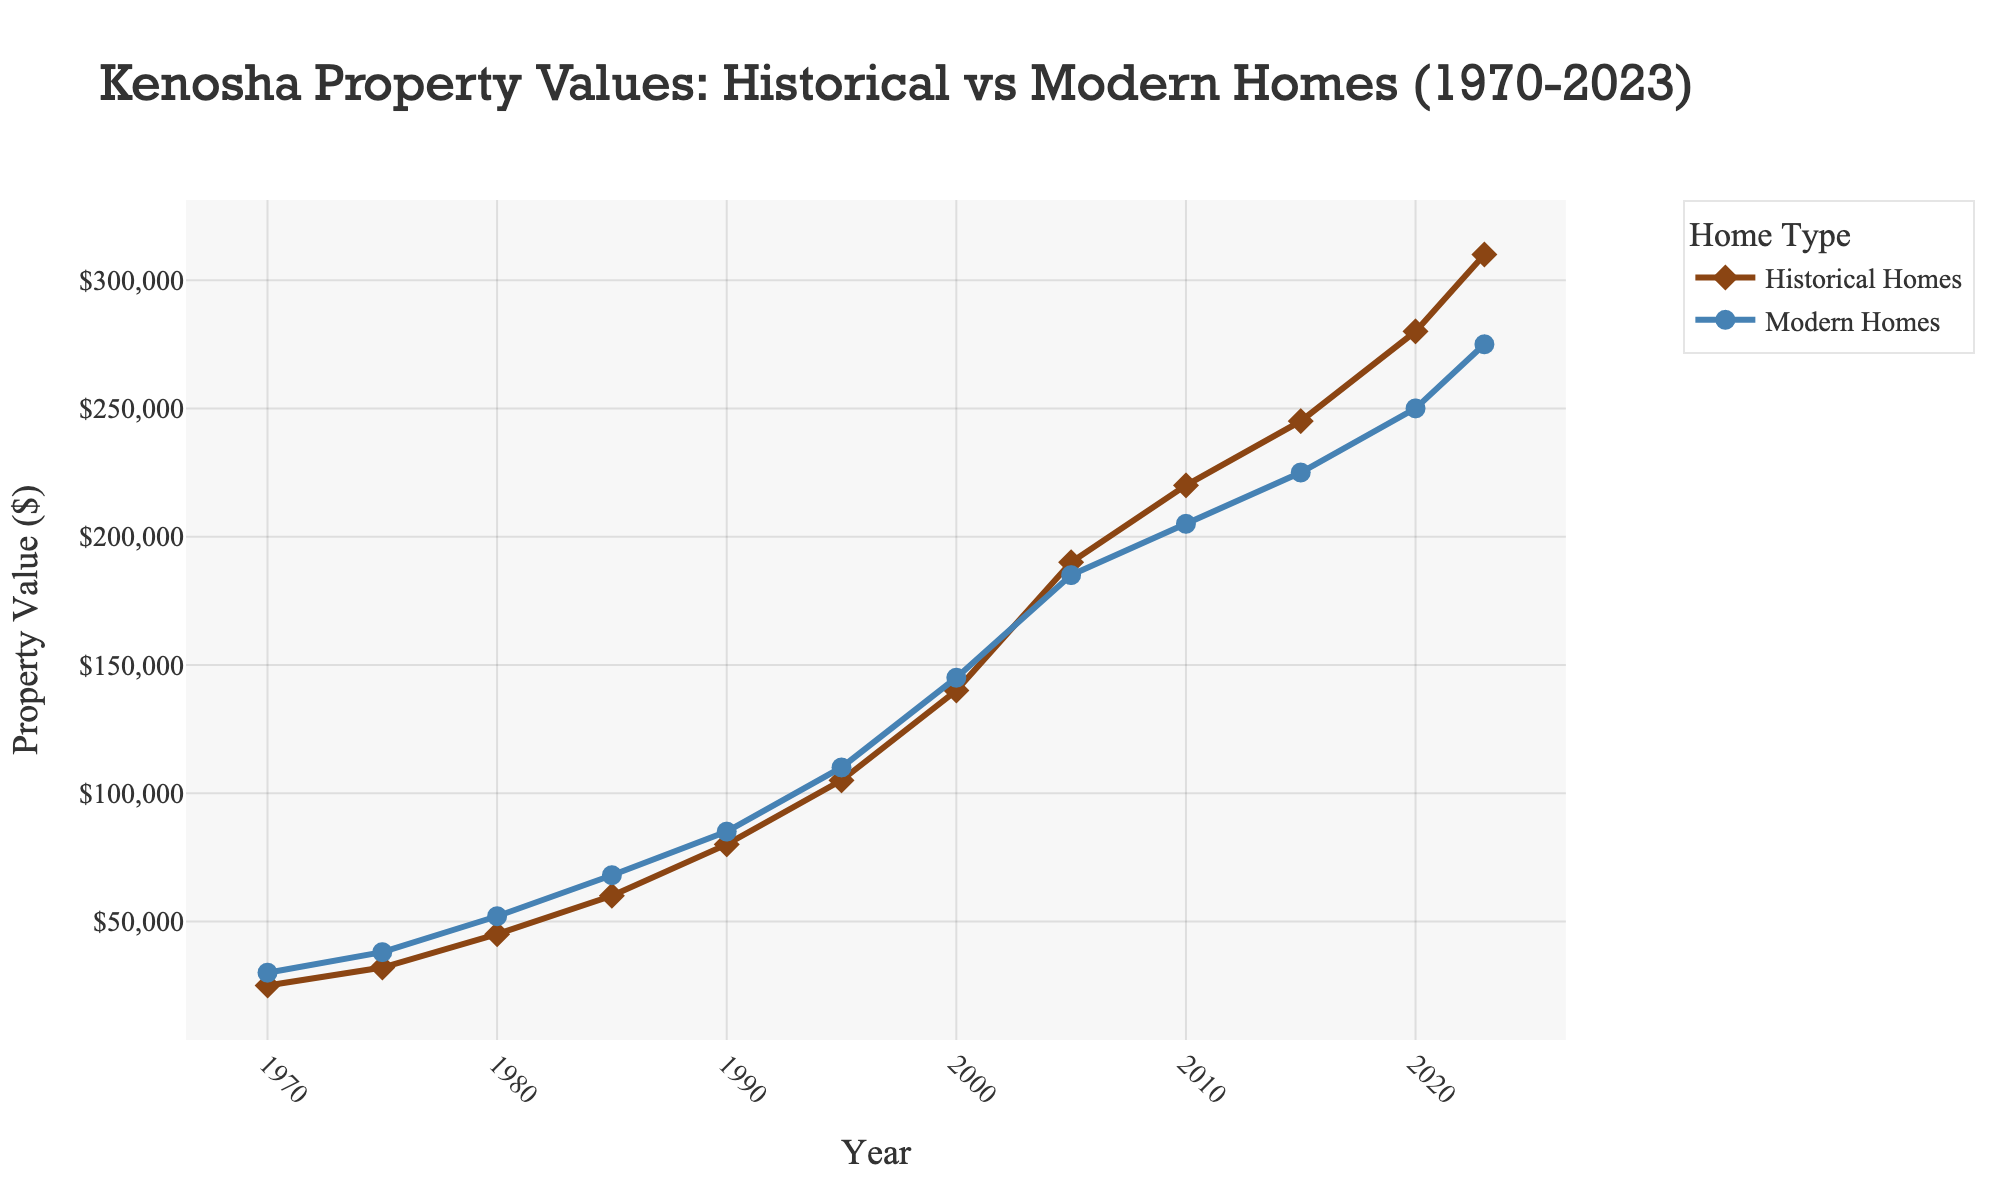What's the overall trend in property values for historical homes from 1970 to 2023? By observing the line plot for historical homes, the property values consistently increase over time from 1970 to 2023. This can be seen by the upward slope of the line representing historical homes.
Answer: Increasing Between historical homes and modern homes, which category had a higher increase in property value from 1970 to 2023? In 1970, historical homes started at $25,000 and reached $310,000 in 2023, an increase of $285,000. Modern homes started at $30,000 in 1970 and reached $275,000 in 2023, an increase of $245,000. Therefore, historical homes had a higher increase.
Answer: Historical homes In which year did the property values of historical homes surpass those of modern homes? By examining the plot, in 2005, the property values for historical homes ($190,000) exceeded those of modern homes ($185,000) for the first time.
Answer: 2005 What was the property value of modern homes in the year 2010? Locate the point on the line representing modern homes for the year 2010, which shows the property value as $205,000.
Answer: $205,000 How much did the property value of historical homes change between 2000 and 2010? In 2000, the property value of historical homes was $140,000, and by 2010 it increased to $220,000. The change is $220,000 - $140,000 = $80,000.
Answer: $80,000 Which year had the smallest difference in property values between historical and modern homes, and what was the difference? By comparing the values year by year, in 1990, the difference was the smallest: $85,000 (modern homes) - $80,000 (historical homes) = $5,000.
Answer: 1990, $5,000 Compare the property value growth rates for historical homes from 1995 to 2000 and modern homes from 2015 to 2020. Which grew faster? Historical homes from 1995 to 2000: ($140,000 - $105,000)/$105,000 = 33.33%. Modern homes from 2015 to 2020: ($250,000 - $225,000)/$225,000 = 11.11%. Historical homes grew faster.
Answer: Historical homes What are the visual markers used in the figure to differentiate between historical and modern homes? Historical homes are represented by diamond shapes with brown lines, while modern homes are represented by circle shapes with blue lines.
Answer: Diamonds and circles What was the percentage increase in property value for modern homes from 1985 to 1990? 1985 value: $68,000, 1990 value: $85,000. Percentage increase: (($85,000 - $68,000) / $68,000) * 100 ≈ 25%.
Answer: 25% 